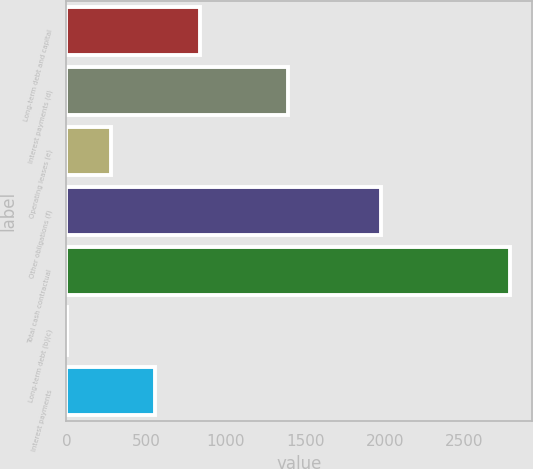Convert chart. <chart><loc_0><loc_0><loc_500><loc_500><bar_chart><fcel>Long-term debt and capital<fcel>Interest payments (d)<fcel>Operating leases (e)<fcel>Other obligations (f)<fcel>Total cash contractual<fcel>Long-term debt (b)(c)<fcel>Interest payments<nl><fcel>835.6<fcel>1392<fcel>279.2<fcel>1972<fcel>2783<fcel>1<fcel>557.4<nl></chart> 